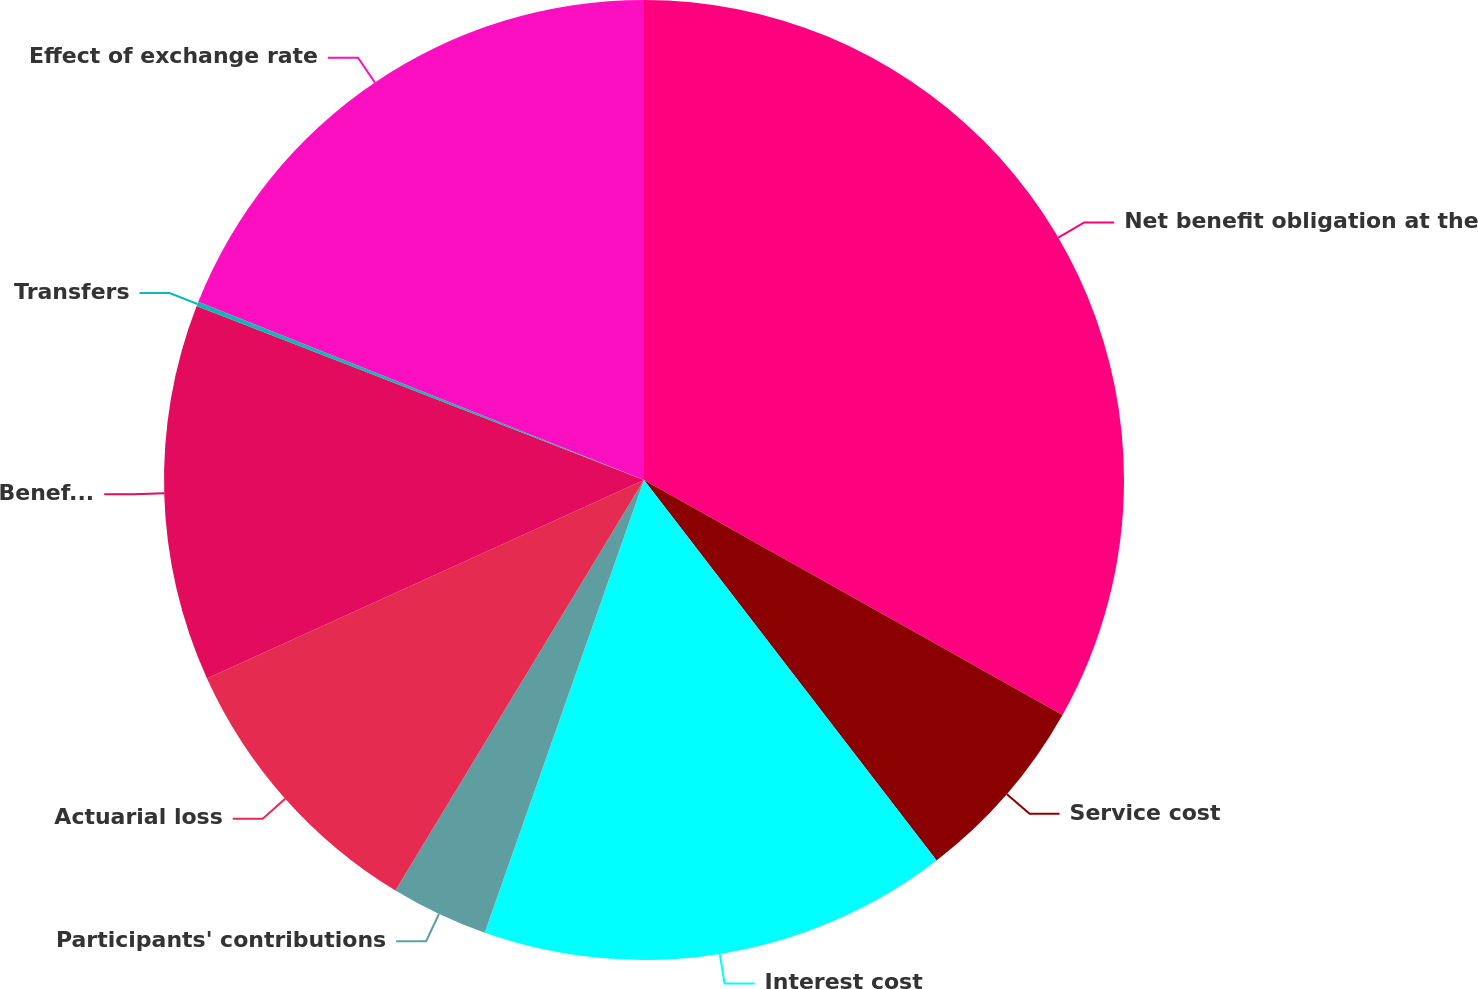Convert chart to OTSL. <chart><loc_0><loc_0><loc_500><loc_500><pie_chart><fcel>Net benefit obligation at the<fcel>Service cost<fcel>Interest cost<fcel>Participants' contributions<fcel>Actuarial loss<fcel>Benefits paid<fcel>Transfers<fcel>Effect of exchange rate<nl><fcel>33.15%<fcel>6.42%<fcel>15.82%<fcel>3.28%<fcel>9.55%<fcel>12.69%<fcel>0.15%<fcel>18.95%<nl></chart> 